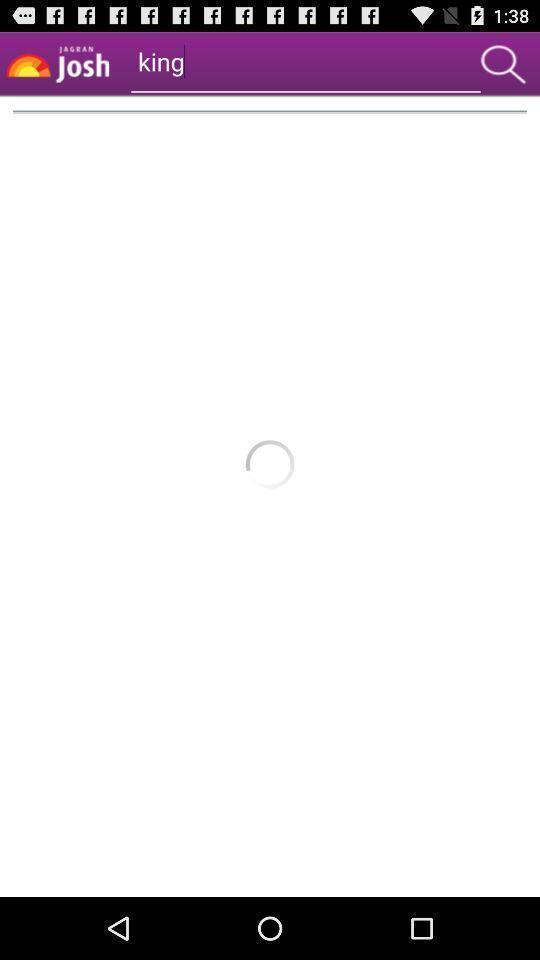What details can you identify in this image? Screen shows search option. 